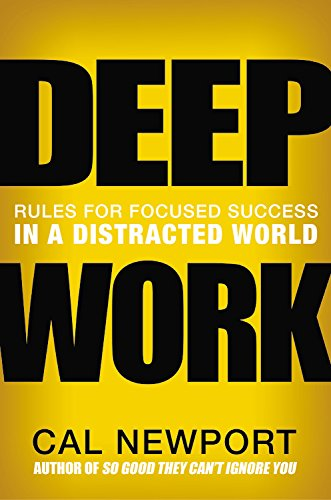Who is the author of this book? The author of 'Deep Work' is Cal Newport, a renowned author known for his insightful perspectives on technology and its impacts on society and professional life. 